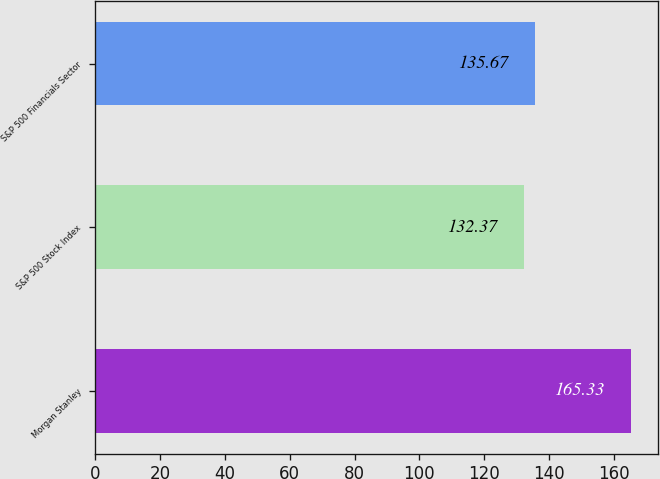Convert chart to OTSL. <chart><loc_0><loc_0><loc_500><loc_500><bar_chart><fcel>Morgan Stanley<fcel>S&P 500 Stock Index<fcel>S&P 500 Financials Sector<nl><fcel>165.33<fcel>132.37<fcel>135.67<nl></chart> 